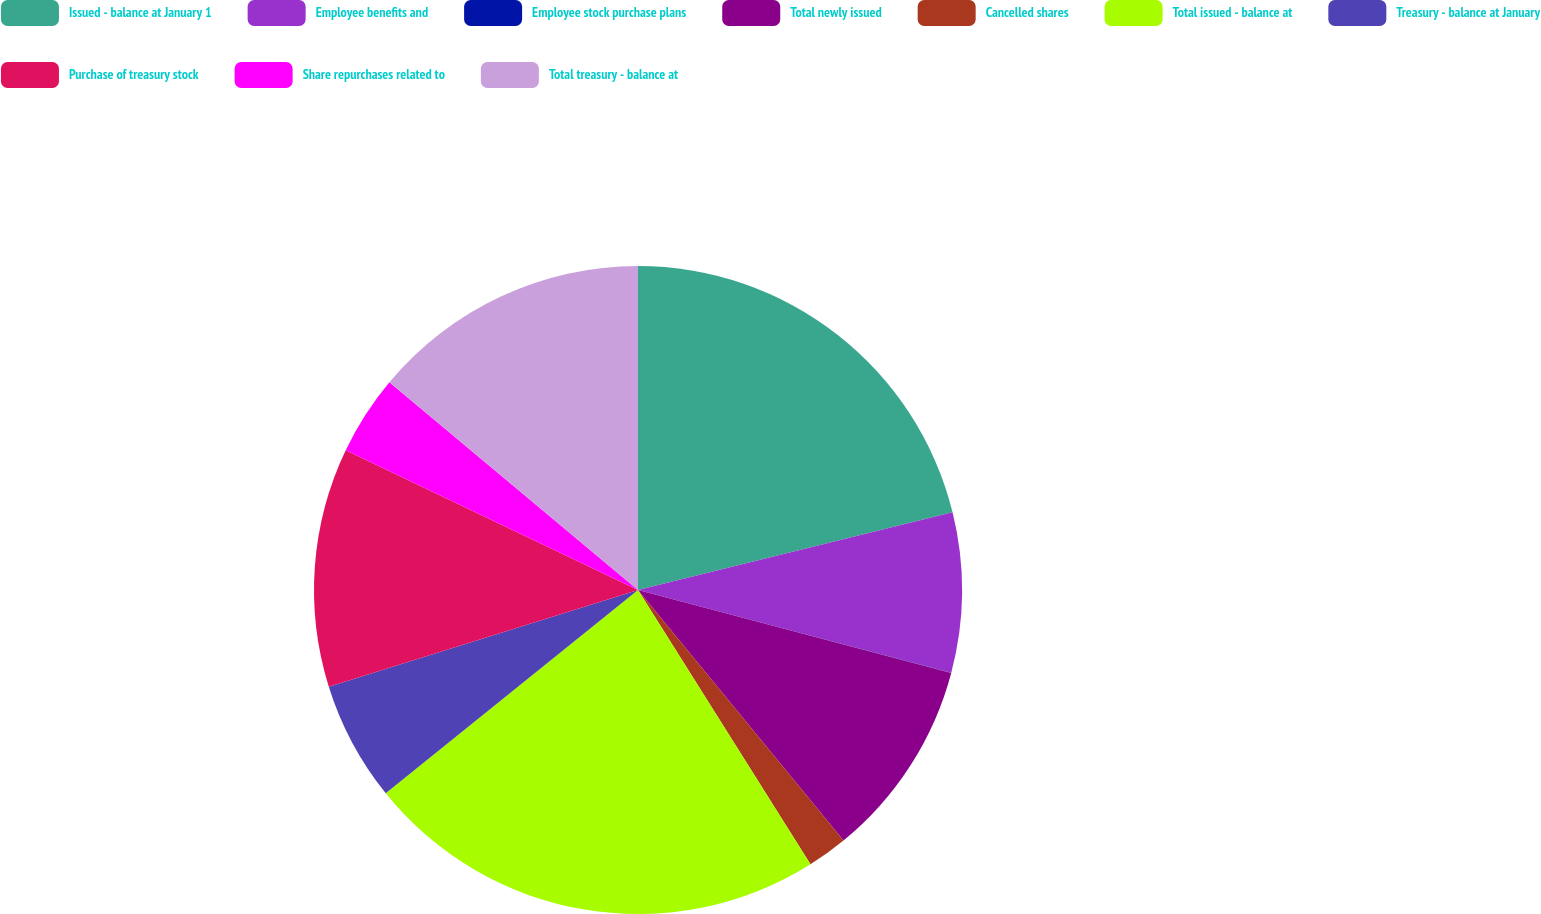Convert chart. <chart><loc_0><loc_0><loc_500><loc_500><pie_chart><fcel>Issued - balance at January 1<fcel>Employee benefits and<fcel>Employee stock purchase plans<fcel>Total newly issued<fcel>Cancelled shares<fcel>Total issued - balance at<fcel>Treasury - balance at January<fcel>Purchase of treasury stock<fcel>Share repurchases related to<fcel>Total treasury - balance at<nl><fcel>21.15%<fcel>7.96%<fcel>0.01%<fcel>9.95%<fcel>2.0%<fcel>23.14%<fcel>5.97%<fcel>11.93%<fcel>3.98%<fcel>13.92%<nl></chart> 